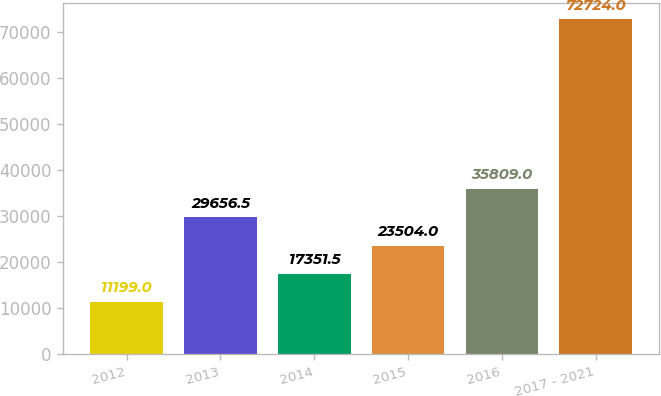Convert chart. <chart><loc_0><loc_0><loc_500><loc_500><bar_chart><fcel>2012<fcel>2013<fcel>2014<fcel>2015<fcel>2016<fcel>2017 - 2021<nl><fcel>11199<fcel>29656.5<fcel>17351.5<fcel>23504<fcel>35809<fcel>72724<nl></chart> 